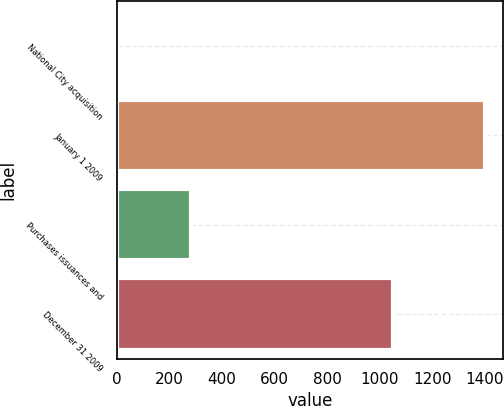Convert chart. <chart><loc_0><loc_0><loc_500><loc_500><bar_chart><fcel>National City acquisition<fcel>January 1 2009<fcel>Purchases issuances and<fcel>December 31 2009<nl><fcel>1<fcel>1401<fcel>283<fcel>1050<nl></chart> 